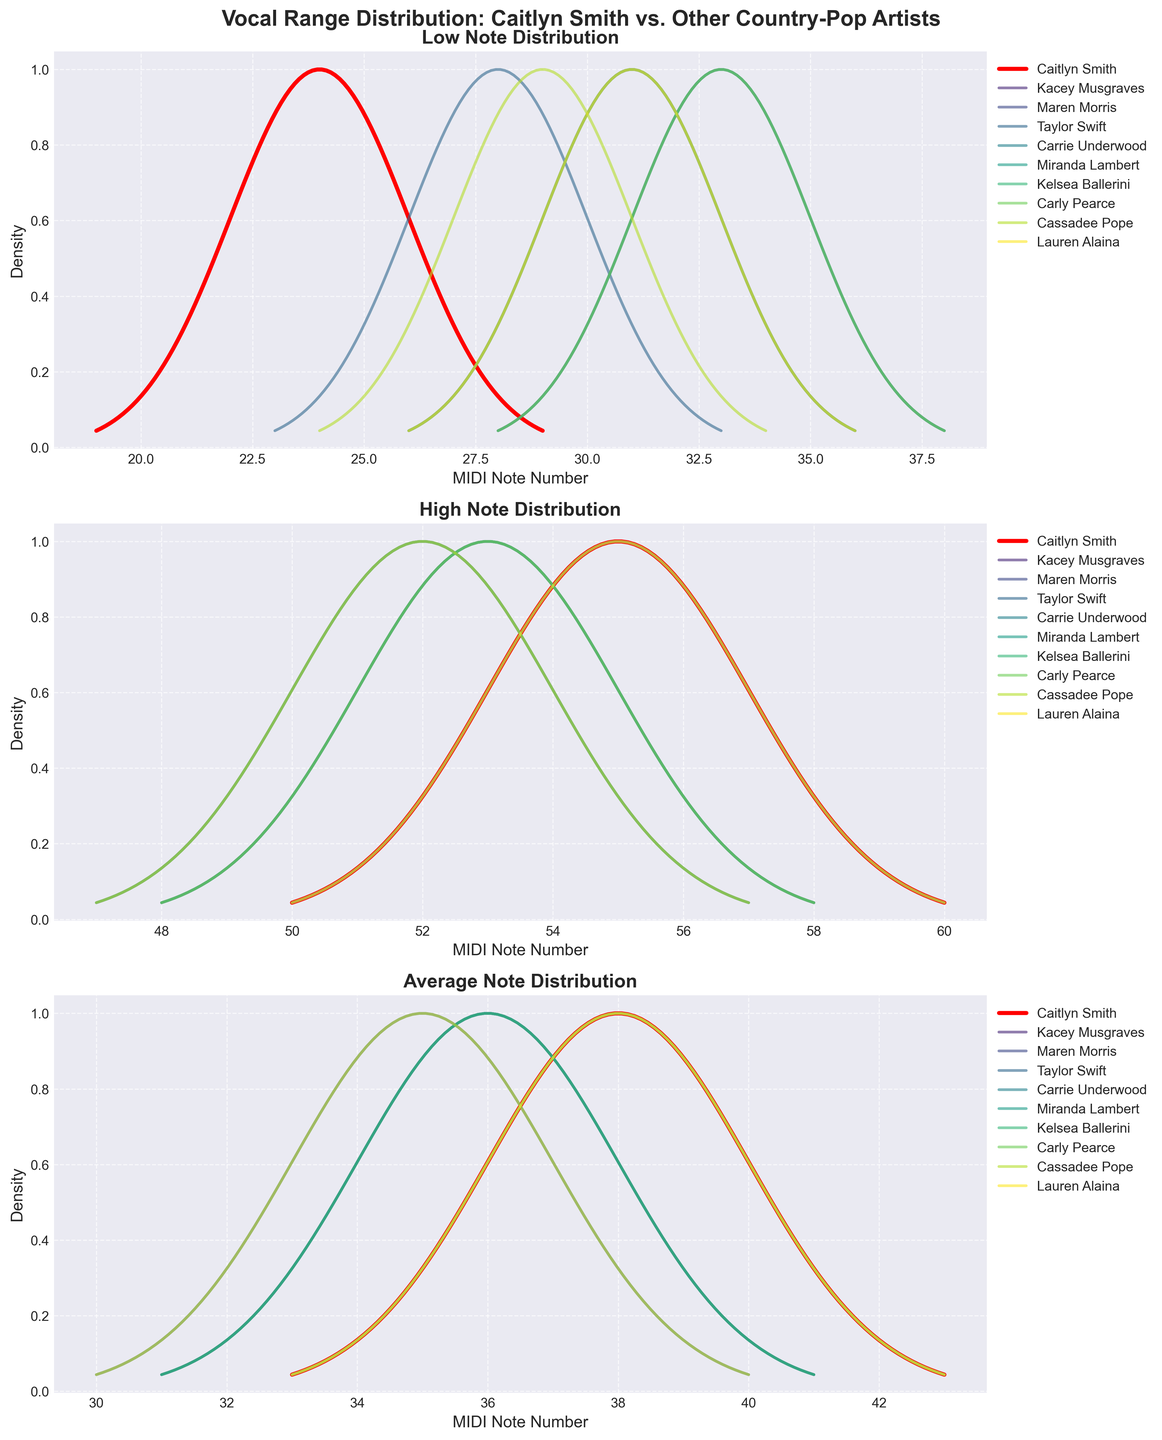Which artist has the highest peak in the Low Note Distribution subplot? The artist with the highest peak in the Low Note Distribution subplot has the densest distribution curve at the highest point. This can be easily seen by comparing the heights of the peaks in the Low Note Distribution subplot.
Answer: Caitlyn Smith How does the High Note Distribution of Caitlyn Smith compare to Carrie Underwood? To compare Caitlyn Smith's High Note Distribution to Carrie Underwood's, observe their curves in the High Note Distribution subplot. Caitlyn Smith's curve is in red, while Carrie Underwood's curve will be one of the other colors. Determine which curve is higher or more spread out.
Answer: Caitlyn Smith's curve peaks higher By how many MIDI note numbers is the average note of Caitlyn Smith different from Miranda Lambert? First, identify the peaks of the average note distribution for Caitlyn Smith (red curve) and Miranda Lambert in the Average Note Distribution subplot. Note their MIDI numbers and compute the difference.
Answer: 2 MIDI note numbers What is the general trend in terms of vocal range for the artists presented in the plots? To identify the general trend in vocal range, observe the distribution ranges in the Low Note, High Note, and Average Note subplots. Determine if most vocal ranges are narrow, wide, or centered around specific MIDI note numbers.
Answer: Generally centered around MIDI 48 for Average Notes Which subplot has the widest variation in terms of density curves for all artists? To determine which subplot has the widest variation, look at the spread and diversity of the density curves for each artist in the Low Note, High Note, and Average Note subplots. The subplot with the most spread across different MIDI note numbers and varied curve shapes indicates the widest variation.
Answer: High Note Distribution 